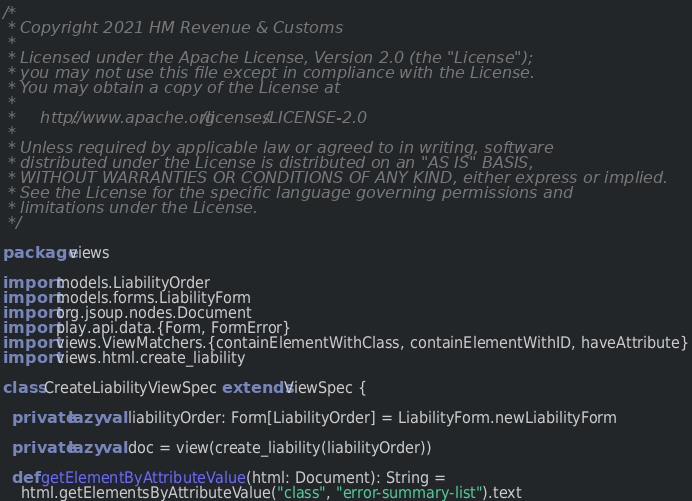Convert code to text. <code><loc_0><loc_0><loc_500><loc_500><_Scala_>/*
 * Copyright 2021 HM Revenue & Customs
 *
 * Licensed under the Apache License, Version 2.0 (the "License");
 * you may not use this file except in compliance with the License.
 * You may obtain a copy of the License at
 *
 *     http://www.apache.org/licenses/LICENSE-2.0
 *
 * Unless required by applicable law or agreed to in writing, software
 * distributed under the License is distributed on an "AS IS" BASIS,
 * WITHOUT WARRANTIES OR CONDITIONS OF ANY KIND, either express or implied.
 * See the License for the specific language governing permissions and
 * limitations under the License.
 */

package views

import models.LiabilityOrder
import models.forms.LiabilityForm
import org.jsoup.nodes.Document
import play.api.data.{Form, FormError}
import views.ViewMatchers.{containElementWithClass, containElementWithID, haveAttribute}
import views.html.create_liability

class CreateLiabilityViewSpec extends ViewSpec {

  private lazy val liabilityOrder: Form[LiabilityOrder] = LiabilityForm.newLiabilityForm

  private lazy val doc = view(create_liability(liabilityOrder))

  def getElementByAttributeValue(html: Document): String =
    html.getElementsByAttributeValue("class", "error-summary-list").text
</code> 